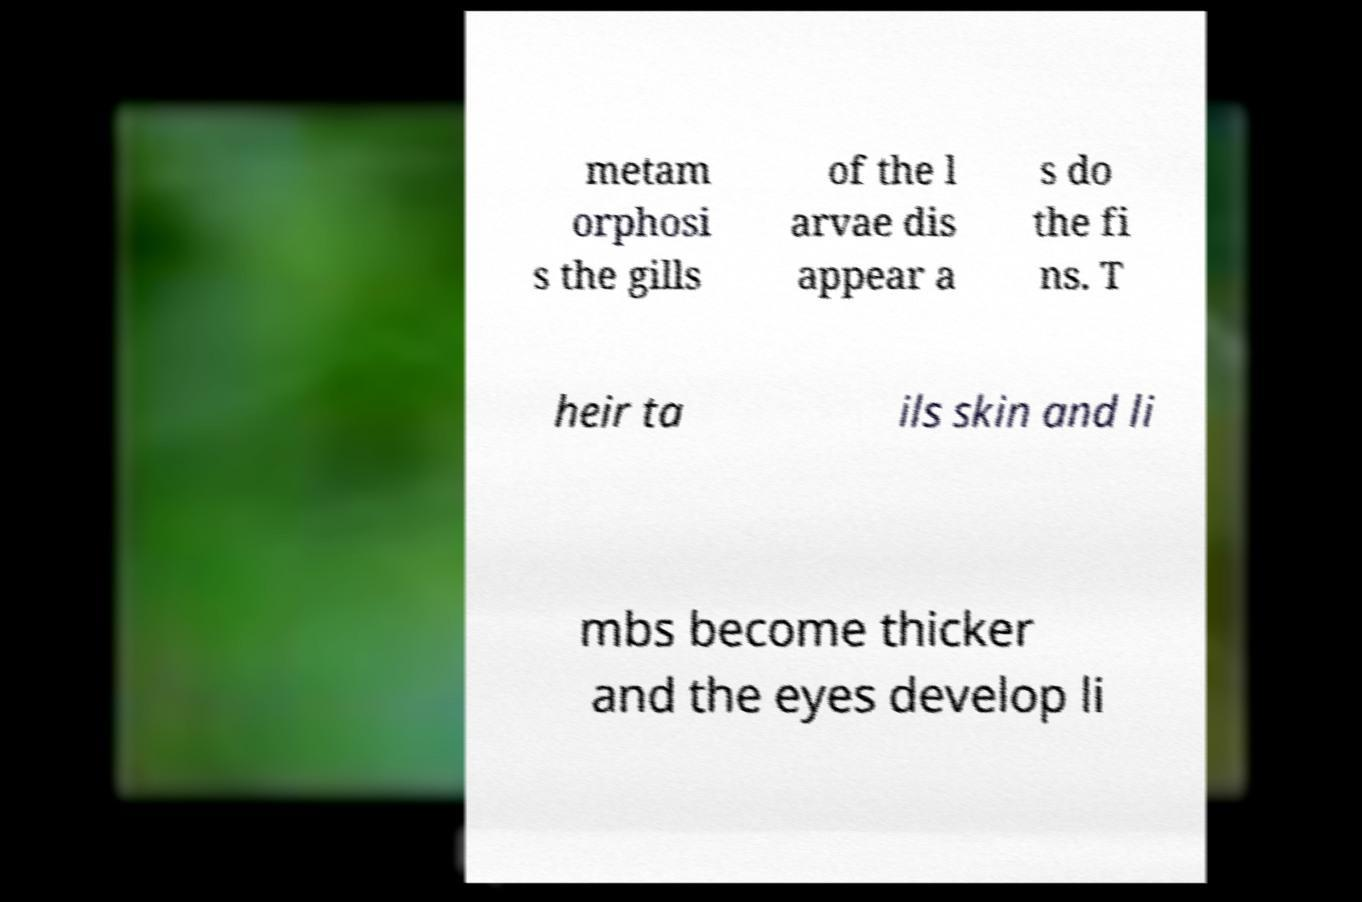Can you accurately transcribe the text from the provided image for me? metam orphosi s the gills of the l arvae dis appear a s do the fi ns. T heir ta ils skin and li mbs become thicker and the eyes develop li 